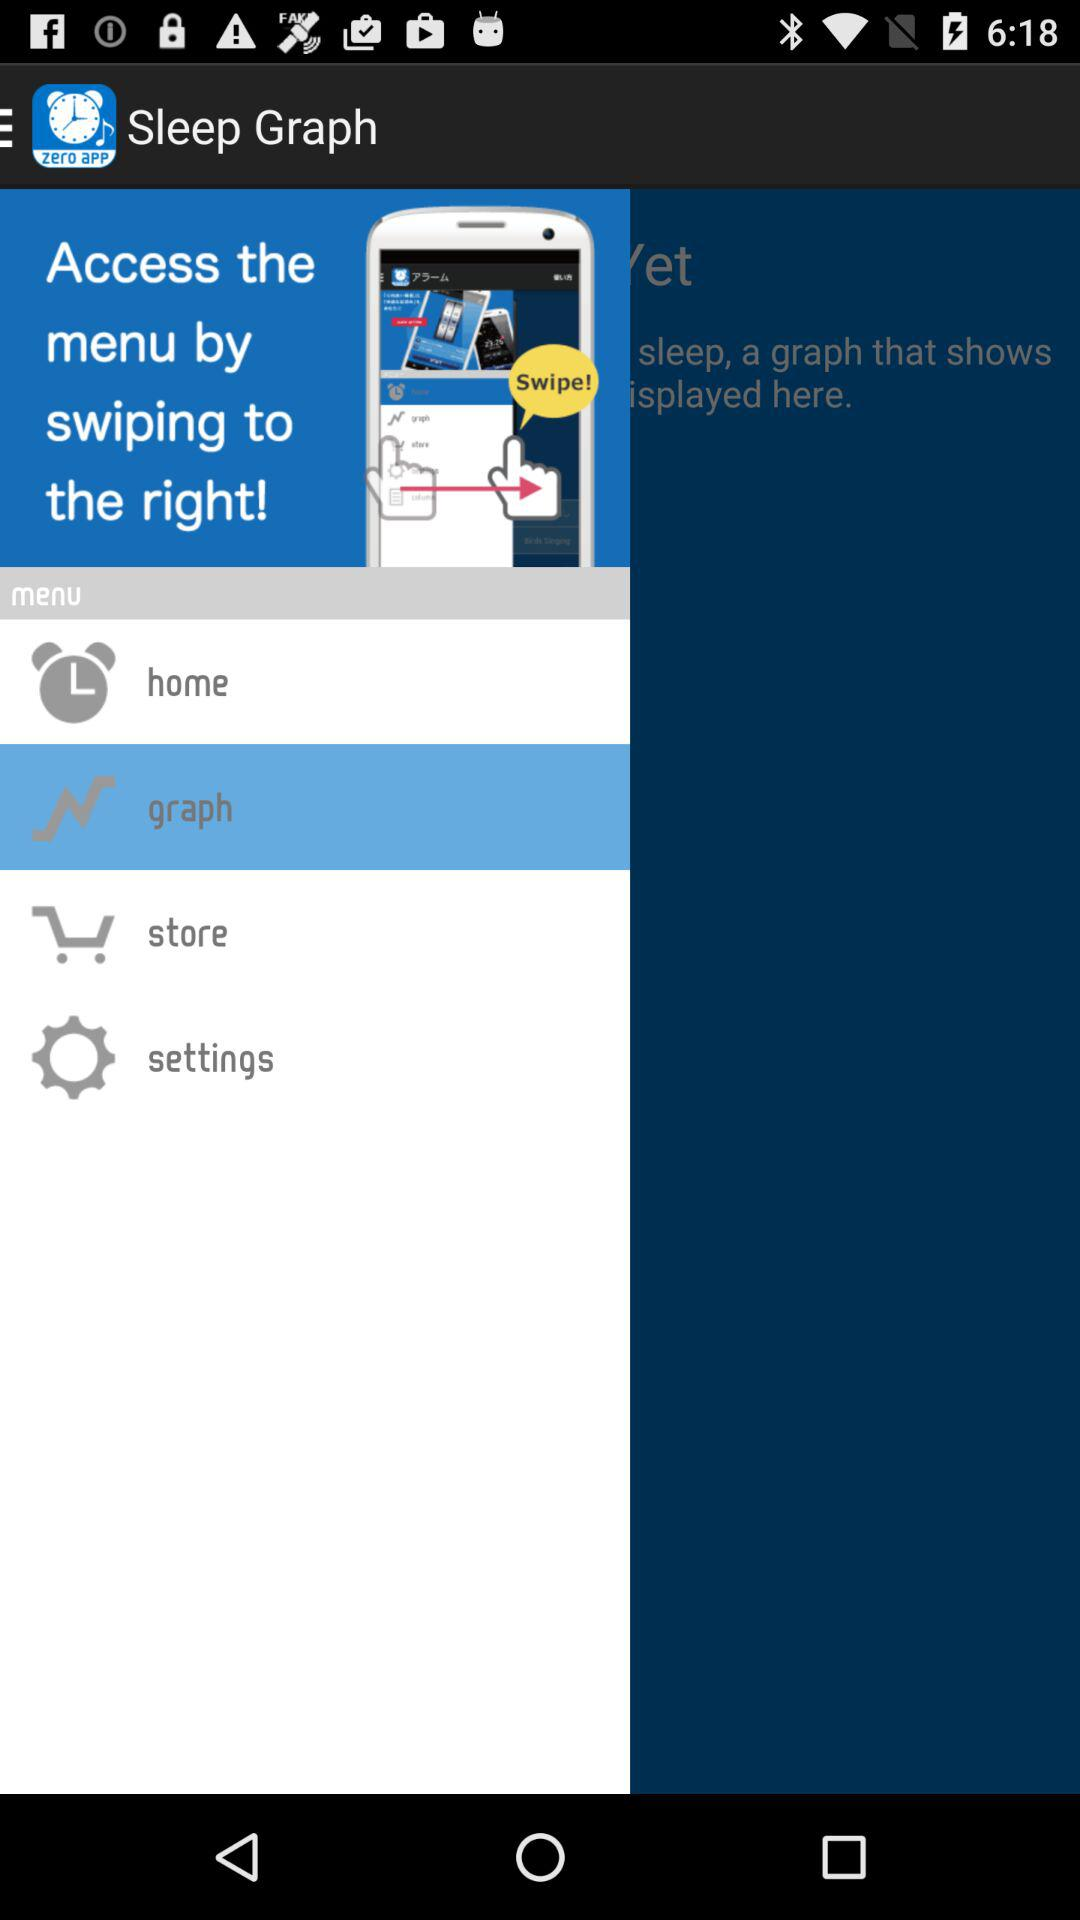How many notifications are there in "settings"?
When the provided information is insufficient, respond with <no answer>. <no answer> 